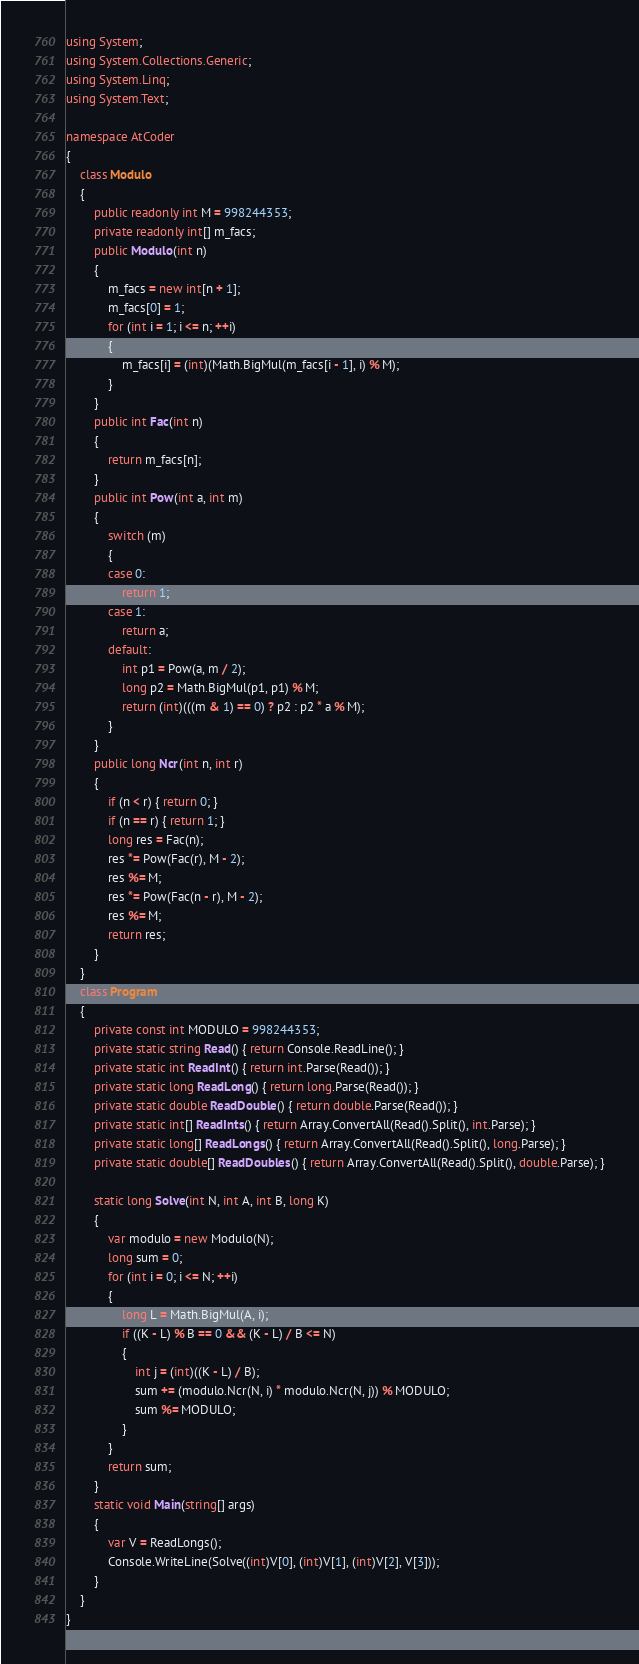<code> <loc_0><loc_0><loc_500><loc_500><_C#_>using System;
using System.Collections.Generic;
using System.Linq;
using System.Text;

namespace AtCoder
{
    class Modulo
    {
        public readonly int M = 998244353;
        private readonly int[] m_facs;
        public Modulo(int n)
        {
            m_facs = new int[n + 1];
            m_facs[0] = 1;
            for (int i = 1; i <= n; ++i)
            {
                m_facs[i] = (int)(Math.BigMul(m_facs[i - 1], i) % M);
            }
        }
        public int Fac(int n)
        {
            return m_facs[n];
        }
        public int Pow(int a, int m)
        {
            switch (m)
            {
            case 0:
                return 1;
            case 1:
                return a;
            default:
                int p1 = Pow(a, m / 2);
                long p2 = Math.BigMul(p1, p1) % M;
                return (int)(((m & 1) == 0) ? p2 : p2 * a % M);
            }
        }
        public long Ncr(int n, int r)
        {
            if (n < r) { return 0; }
            if (n == r) { return 1; }
            long res = Fac(n);
            res *= Pow(Fac(r), M - 2);
            res %= M;
            res *= Pow(Fac(n - r), M - 2);
            res %= M;
            return res;
        }
    }
    class Program
    {
        private const int MODULO = 998244353;
        private static string Read() { return Console.ReadLine(); }
        private static int ReadInt() { return int.Parse(Read()); }
        private static long ReadLong() { return long.Parse(Read()); }
        private static double ReadDouble() { return double.Parse(Read()); }
        private static int[] ReadInts() { return Array.ConvertAll(Read().Split(), int.Parse); }
        private static long[] ReadLongs() { return Array.ConvertAll(Read().Split(), long.Parse); }
        private static double[] ReadDoubles() { return Array.ConvertAll(Read().Split(), double.Parse); }

        static long Solve(int N, int A, int B, long K)
        {
            var modulo = new Modulo(N);
            long sum = 0;
            for (int i = 0; i <= N; ++i)
            {
                long L = Math.BigMul(A, i);
                if ((K - L) % B == 0 && (K - L) / B <= N)
                {
                    int j = (int)((K - L) / B);
                    sum += (modulo.Ncr(N, i) * modulo.Ncr(N, j)) % MODULO;
                    sum %= MODULO;
                }
            }
            return sum;
        }
        static void Main(string[] args)
        {
            var V = ReadLongs();
            Console.WriteLine(Solve((int)V[0], (int)V[1], (int)V[2], V[3]));
        }
    }
}
</code> 